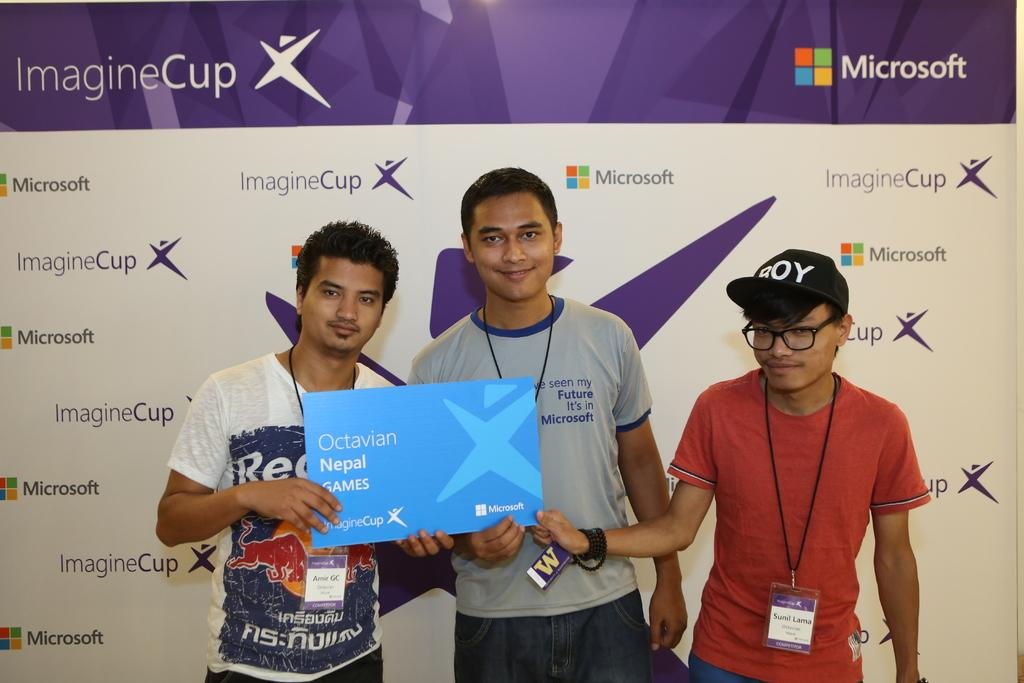How many people are in the image? There are three persons in the image. What are the persons holding in the image? The persons are holding a board with text on it. What can be seen on the persons' clothing? The persons are wearing access cards. What is visible behind the persons in the image? There is a board with images and text behind them. What type of chalk is being used to write on the board in the image? There is no chalk present in the image; the board has text and images on it. What is the desire of the persons in the image? The image does not provide information about the desires of the persons; it only shows them holding a board with text on it. 